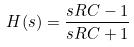<formula> <loc_0><loc_0><loc_500><loc_500>H ( s ) = \frac { s R C - 1 } { s R C + 1 }</formula> 